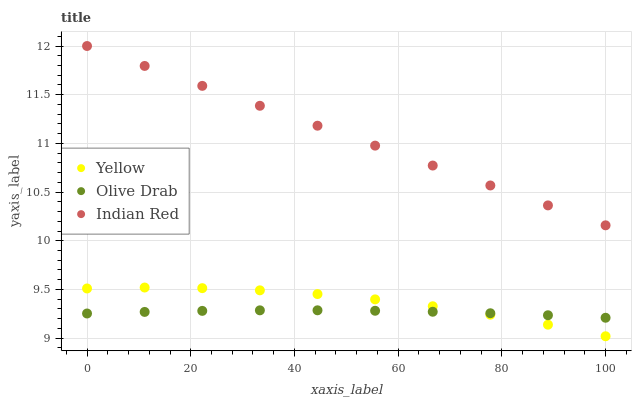Does Olive Drab have the minimum area under the curve?
Answer yes or no. Yes. Does Indian Red have the maximum area under the curve?
Answer yes or no. Yes. Does Yellow have the minimum area under the curve?
Answer yes or no. No. Does Yellow have the maximum area under the curve?
Answer yes or no. No. Is Indian Red the smoothest?
Answer yes or no. Yes. Is Yellow the roughest?
Answer yes or no. Yes. Is Olive Drab the smoothest?
Answer yes or no. No. Is Olive Drab the roughest?
Answer yes or no. No. Does Yellow have the lowest value?
Answer yes or no. Yes. Does Olive Drab have the lowest value?
Answer yes or no. No. Does Indian Red have the highest value?
Answer yes or no. Yes. Does Yellow have the highest value?
Answer yes or no. No. Is Olive Drab less than Indian Red?
Answer yes or no. Yes. Is Indian Red greater than Yellow?
Answer yes or no. Yes. Does Yellow intersect Olive Drab?
Answer yes or no. Yes. Is Yellow less than Olive Drab?
Answer yes or no. No. Is Yellow greater than Olive Drab?
Answer yes or no. No. Does Olive Drab intersect Indian Red?
Answer yes or no. No. 